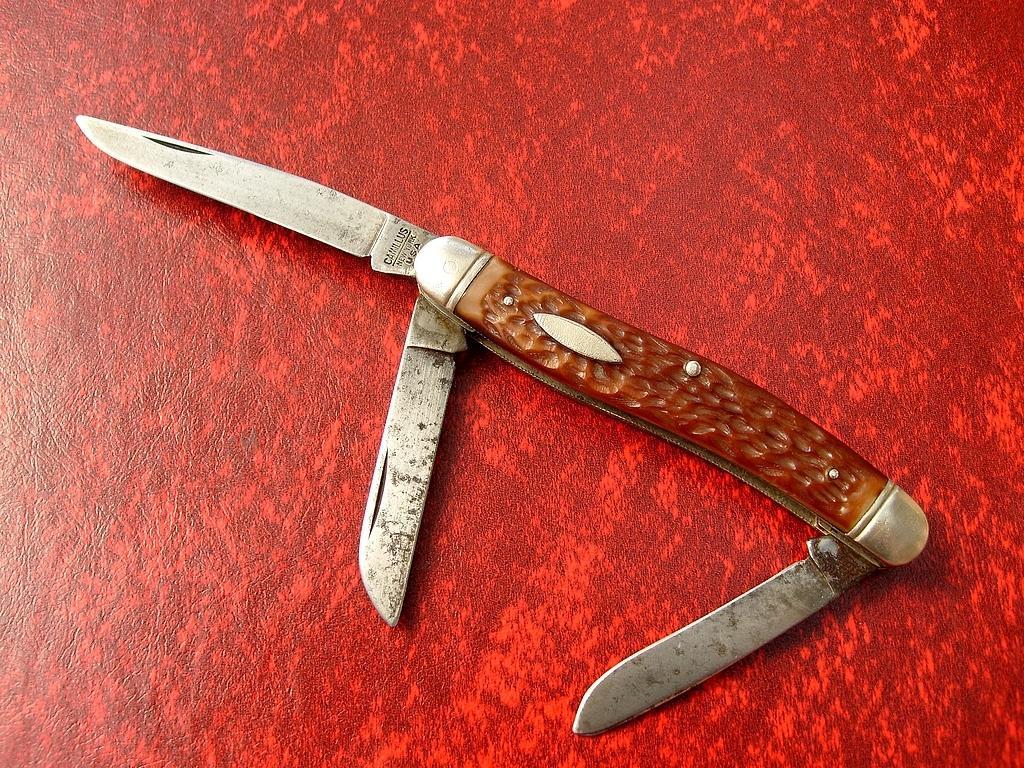In one or two sentences, can you explain what this image depicts? In the foreground of this image, there are three plates to a folding knife on a red color surface. 